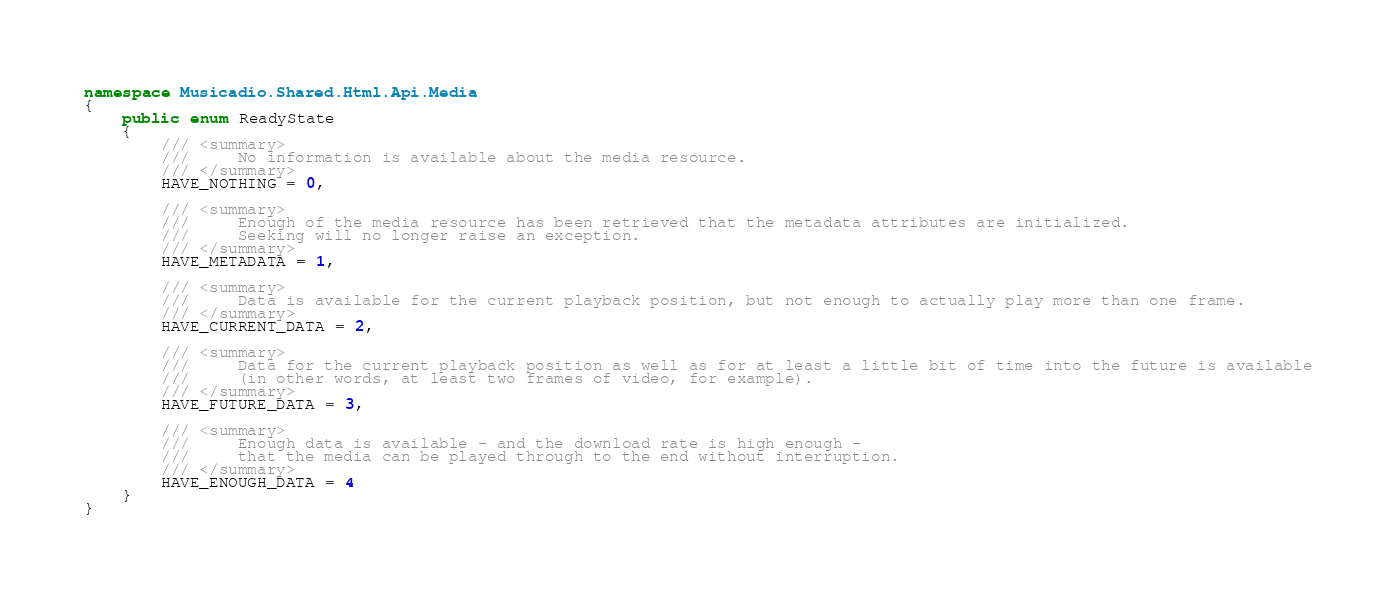Convert code to text. <code><loc_0><loc_0><loc_500><loc_500><_C#_>namespace Musicadio.Shared.Html.Api.Media
{
    public enum ReadyState
    {
        /// <summary>
        ///     No information is available about the media resource.
        /// </summary>
        HAVE_NOTHING = 0,

        /// <summary>
        ///     Enough of the media resource has been retrieved that the metadata attributes are initialized.
        ///     Seeking will no longer raise an exception.
        /// </summary>
        HAVE_METADATA = 1,

        /// <summary>
        ///     Data is available for the current playback position, but not enough to actually play more than one frame.
        /// </summary>
        HAVE_CURRENT_DATA = 2,

        /// <summary>
        ///     Data for the current playback position as well as for at least a little bit of time into the future is available
        ///     (in other words, at least two frames of video, for example).
        /// </summary>
        HAVE_FUTURE_DATA = 3,

        /// <summary>
        ///     Enough data is available - and the download rate is high enough -
        ///     that the media can be played through to the end without interruption.
        /// </summary>
        HAVE_ENOUGH_DATA = 4
    }
}</code> 